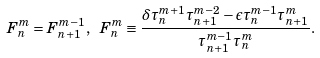<formula> <loc_0><loc_0><loc_500><loc_500>F _ { n } ^ { m } = F _ { n + 1 } ^ { m - 1 } , \ F _ { n } ^ { m } \equiv \frac { \delta \tau _ { n } ^ { m + 1 } \tau _ { n + 1 } ^ { m - 2 } - \epsilon \tau _ { n } ^ { m - 1 } \tau _ { n + 1 } ^ { m } } { \tau _ { n + 1 } ^ { m - 1 } \tau _ { n } ^ { m } } .</formula> 